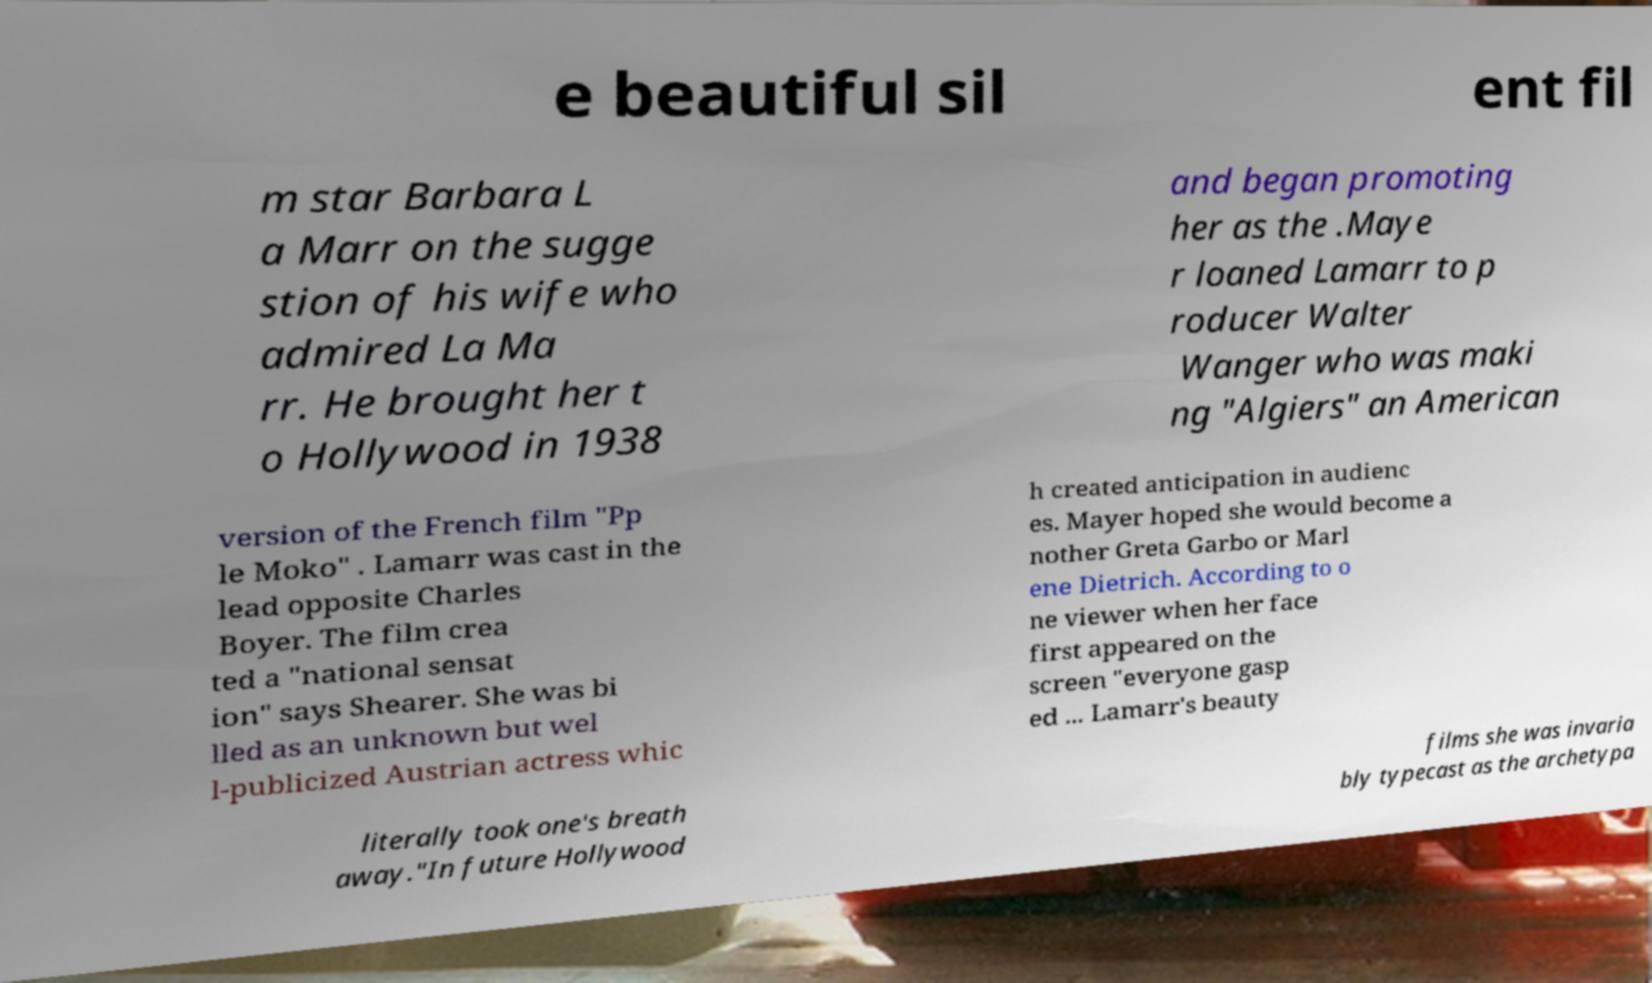Could you extract and type out the text from this image? e beautiful sil ent fil m star Barbara L a Marr on the sugge stion of his wife who admired La Ma rr. He brought her t o Hollywood in 1938 and began promoting her as the .Maye r loaned Lamarr to p roducer Walter Wanger who was maki ng "Algiers" an American version of the French film "Pp le Moko" . Lamarr was cast in the lead opposite Charles Boyer. The film crea ted a "national sensat ion" says Shearer. She was bi lled as an unknown but wel l-publicized Austrian actress whic h created anticipation in audienc es. Mayer hoped she would become a nother Greta Garbo or Marl ene Dietrich. According to o ne viewer when her face first appeared on the screen "everyone gasp ed ... Lamarr's beauty literally took one's breath away."In future Hollywood films she was invaria bly typecast as the archetypa 